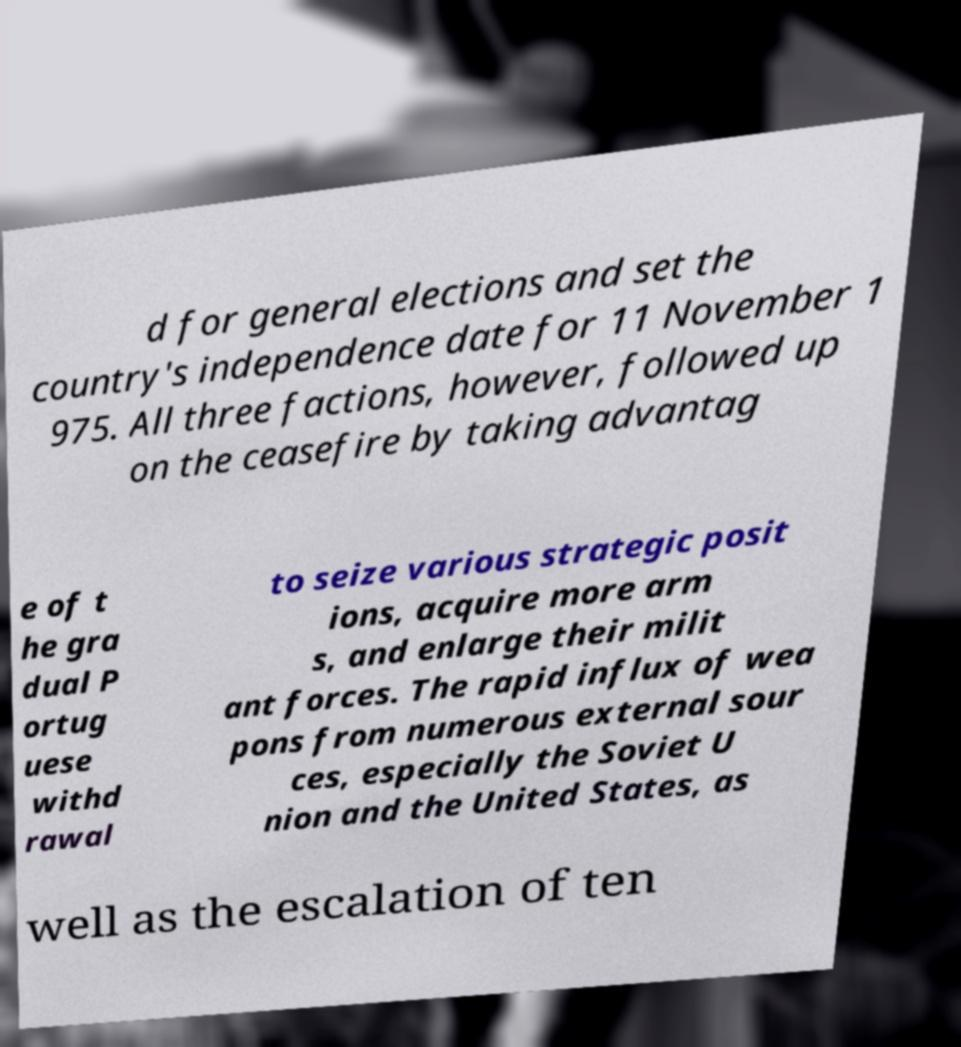For documentation purposes, I need the text within this image transcribed. Could you provide that? d for general elections and set the country's independence date for 11 November 1 975. All three factions, however, followed up on the ceasefire by taking advantag e of t he gra dual P ortug uese withd rawal to seize various strategic posit ions, acquire more arm s, and enlarge their milit ant forces. The rapid influx of wea pons from numerous external sour ces, especially the Soviet U nion and the United States, as well as the escalation of ten 